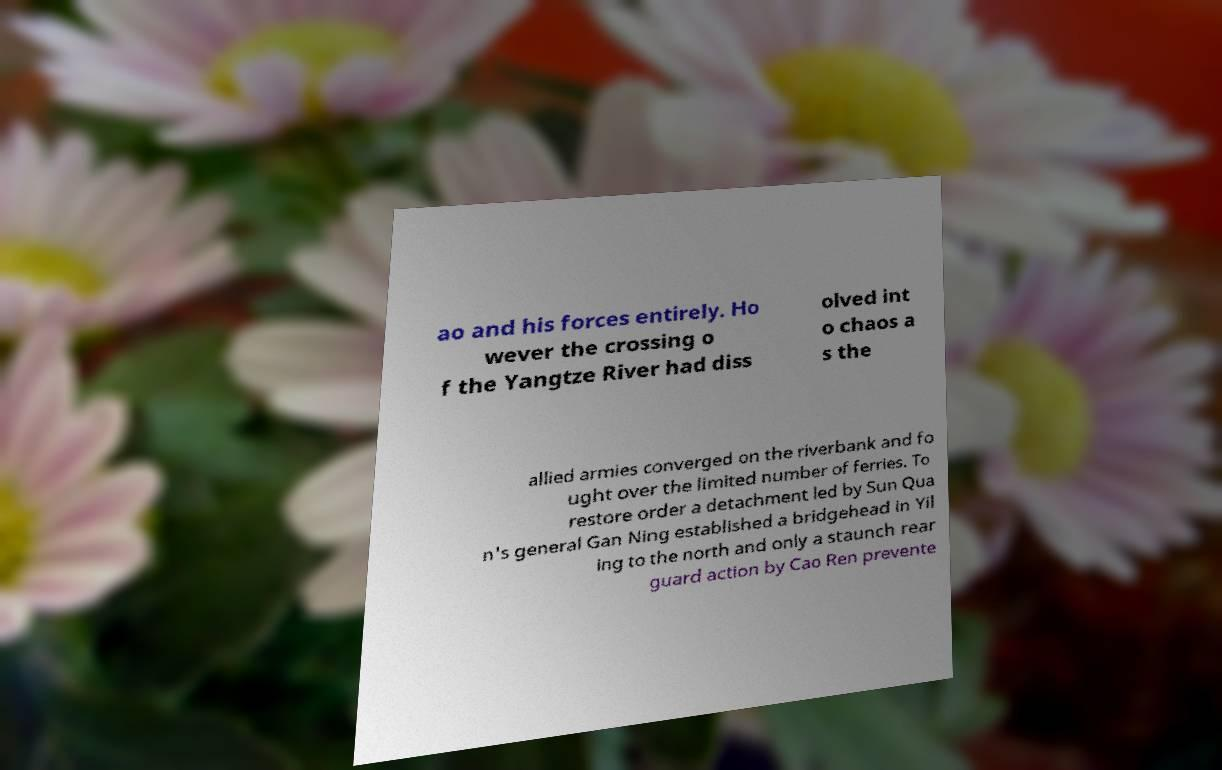Could you extract and type out the text from this image? ao and his forces entirely. Ho wever the crossing o f the Yangtze River had diss olved int o chaos a s the allied armies converged on the riverbank and fo ught over the limited number of ferries. To restore order a detachment led by Sun Qua n's general Gan Ning established a bridgehead in Yil ing to the north and only a staunch rear guard action by Cao Ren prevente 